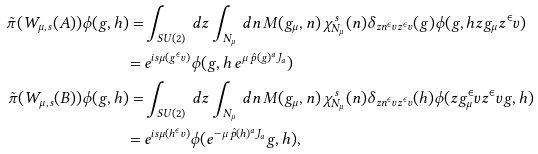<formula> <loc_0><loc_0><loc_500><loc_500>\tilde { \pi } ( W _ { \mu , s } ( A ) ) \phi ( g , h ) = & \int _ { S U ( 2 ) } \, d z \int _ { N _ { \mu } } \, d n \, M ( g _ { \mu } , n ) \, \chi _ { N _ { \mu } } ^ { s } ( n ) \delta _ { z n ^ { \in } v z ^ { \in } v } ( g ) \phi ( g , h z g _ { \mu } z ^ { \in } v ) \\ = \, & e ^ { i s \mu ( g ^ { \in } v ) } \phi ( g , h \, e ^ { \mu \, \hat { p } ( g ) ^ { a } J _ { a } } ) \\ \tilde { \pi } ( W _ { \mu , s } ( B ) ) \phi ( g , h ) = & \int _ { S U ( 2 ) } \, d z \int _ { N _ { \mu } } \, d n \, M ( g _ { \mu } , n ) \, \chi _ { N _ { \mu } } ^ { s } ( n ) \delta _ { z n ^ { \in } v z ^ { \in } v } ( h ) \phi ( z g _ { \mu } ^ { \in } v z ^ { \in } v g , h ) \\ = \, & e ^ { i s \mu ( h ^ { \in } v ) } \phi ( e ^ { - \mu \, \hat { p } ( h ) ^ { a } J _ { a } } g , h ) ,</formula> 